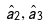<formula> <loc_0><loc_0><loc_500><loc_500>\hat { a } _ { 2 } , \hat { a } _ { 3 }</formula> 